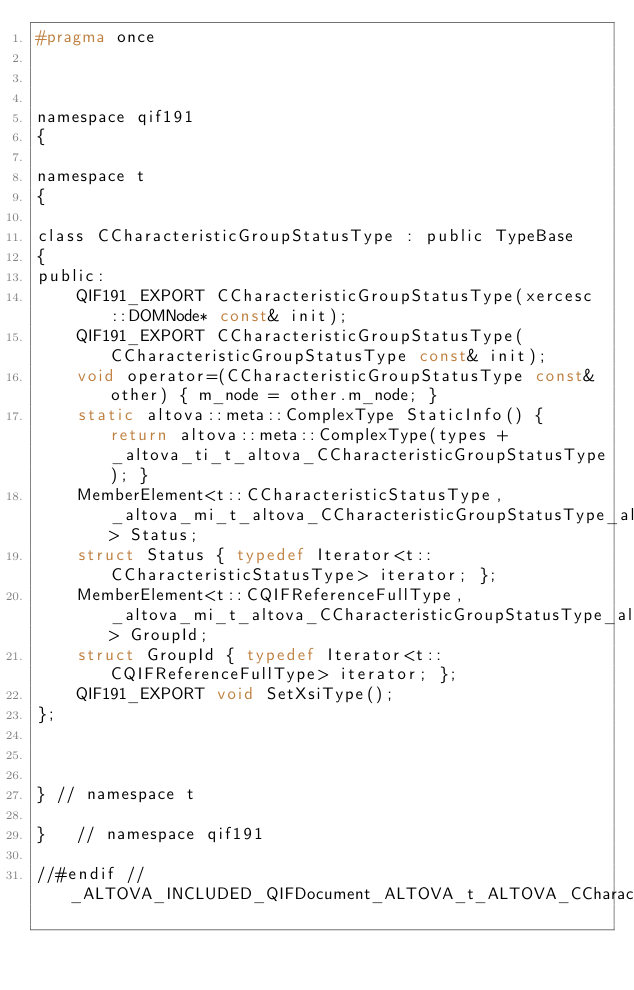Convert code to text. <code><loc_0><loc_0><loc_500><loc_500><_C_>#pragma once



namespace qif191
{

namespace t
{	

class CCharacteristicGroupStatusType : public TypeBase
{
public:
	QIF191_EXPORT CCharacteristicGroupStatusType(xercesc::DOMNode* const& init);
	QIF191_EXPORT CCharacteristicGroupStatusType(CCharacteristicGroupStatusType const& init);
	void operator=(CCharacteristicGroupStatusType const& other) { m_node = other.m_node; }
	static altova::meta::ComplexType StaticInfo() { return altova::meta::ComplexType(types + _altova_ti_t_altova_CCharacteristicGroupStatusType); }
	MemberElement<t::CCharacteristicStatusType, _altova_mi_t_altova_CCharacteristicGroupStatusType_altova_Status> Status;
	struct Status { typedef Iterator<t::CCharacteristicStatusType> iterator; };
	MemberElement<t::CQIFReferenceFullType, _altova_mi_t_altova_CCharacteristicGroupStatusType_altova_GroupId> GroupId;
	struct GroupId { typedef Iterator<t::CQIFReferenceFullType> iterator; };
	QIF191_EXPORT void SetXsiType();
};



} // namespace t

}	// namespace qif191

//#endif // _ALTOVA_INCLUDED_QIFDocument_ALTOVA_t_ALTOVA_CCharacteristicGroupStatusType
</code> 